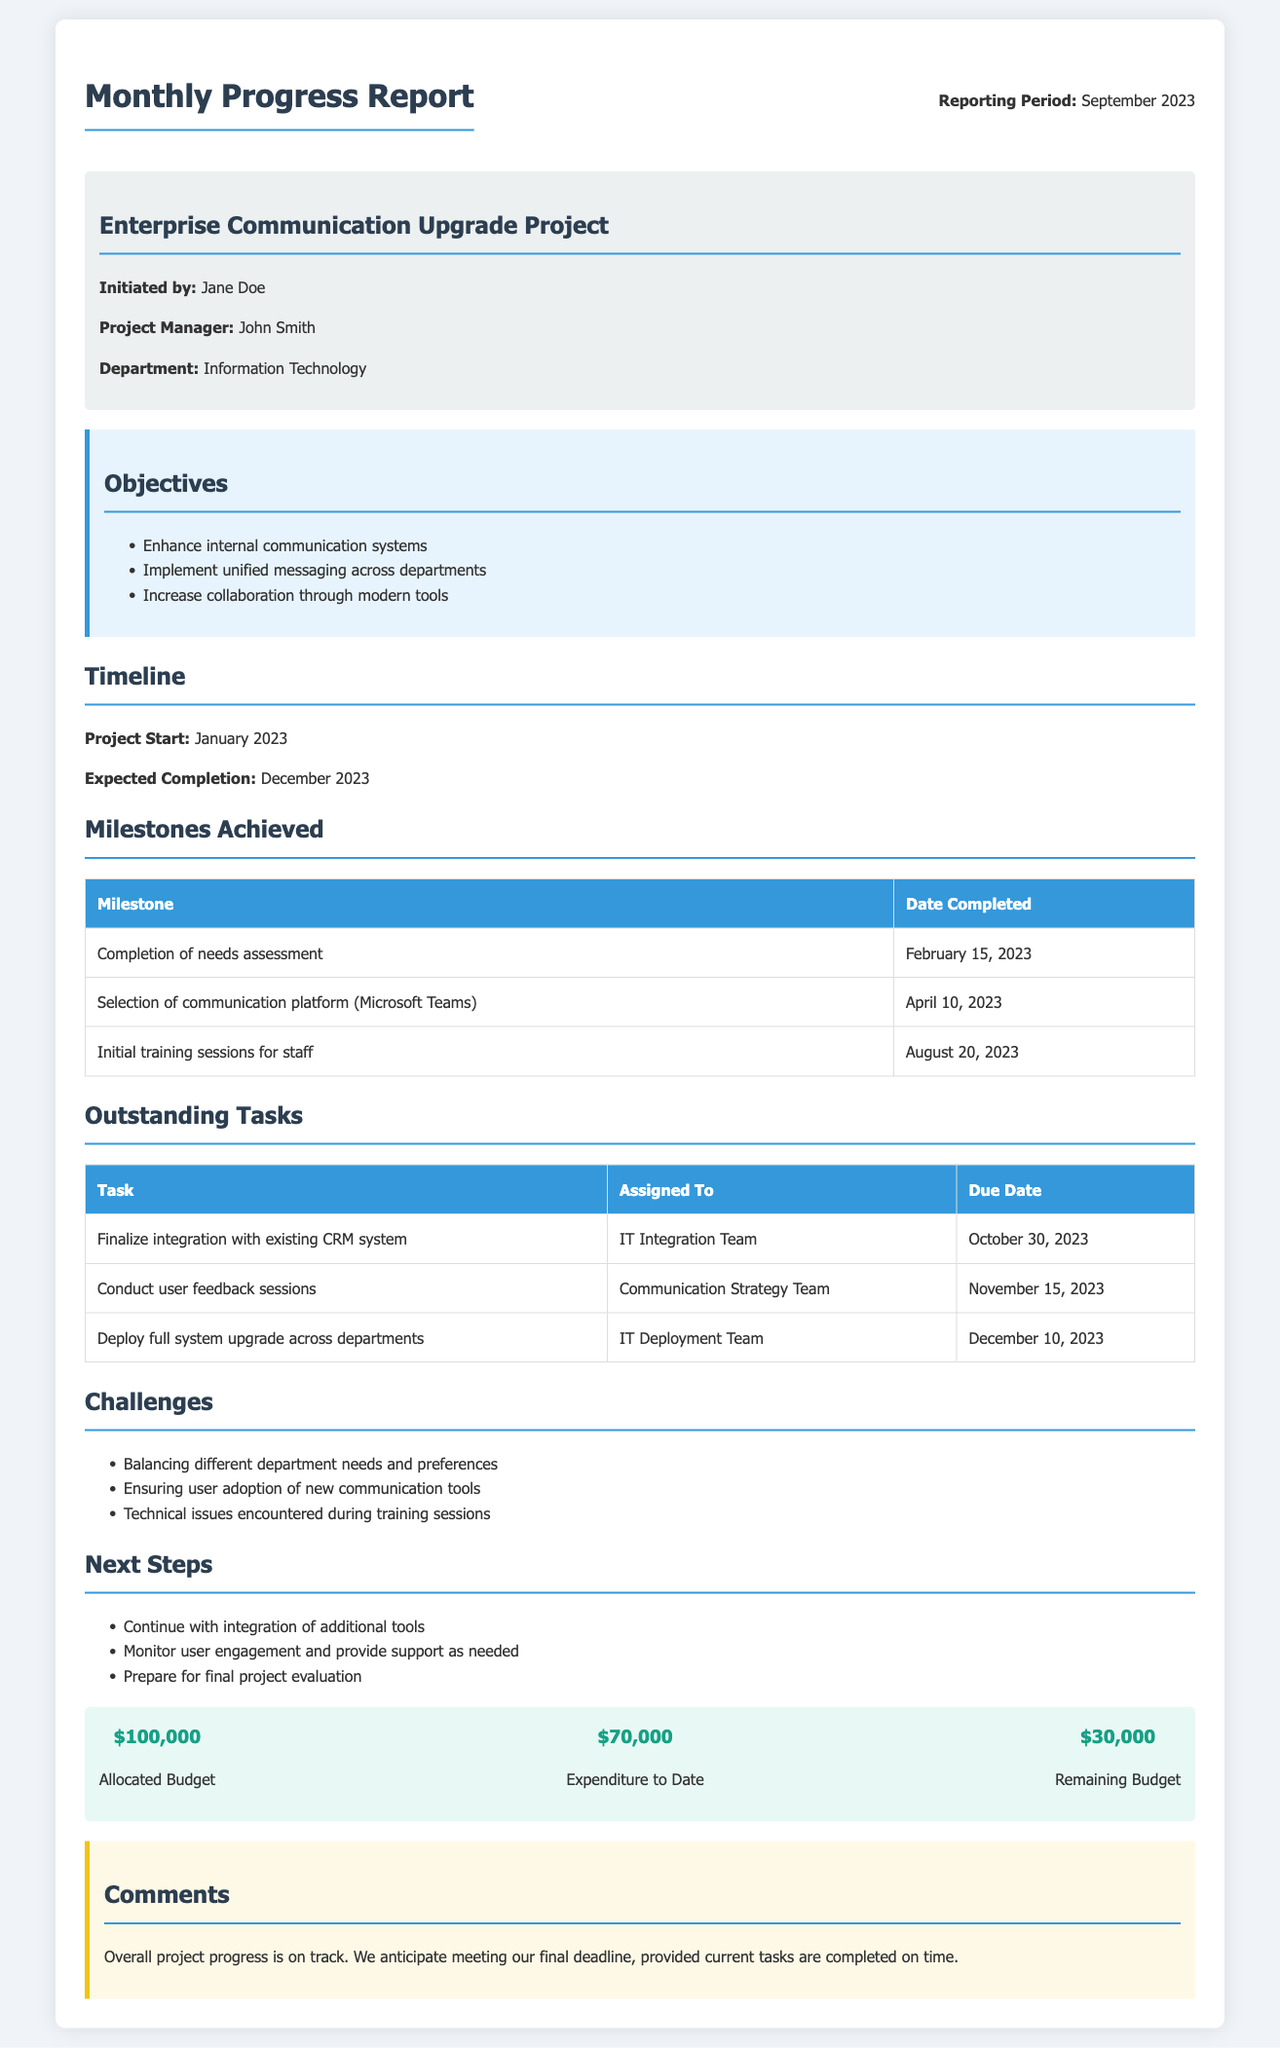What is the project manager's name? The project manager's name is mentioned in the project info section of the document.
Answer: John Smith What is the expected completion date of the project? The expected completion date is provided in the timeline section of the document.
Answer: December 2023 Which platform was selected for communication? The selected communication platform is outlined in the milestones achieved section of the document.
Answer: Microsoft Teams What is the due date for finalizing integration with the existing CRM system? The due date for this task is listed in the outstanding tasks section of the document.
Answer: October 30, 2023 What is the allocated budget for the project? The allocated budget can be found in the budget section of the document.
Answer: $100,000 How many milestones have been achieved so far? The number of milestones achieved can be counted from the milestones achieved section of the document.
Answer: 3 What challenge is related to user adoption? The challenges section of the document includes information about user adoption issues.
Answer: Ensuring user adoption of new communication tools What is the remaining budget? The remaining budget is stated in the budget section of the document.
Answer: $30,000 What is the next step related to user engagement? The next steps section specifies activities regarding user engagement.
Answer: Monitor user engagement and provide support as needed 